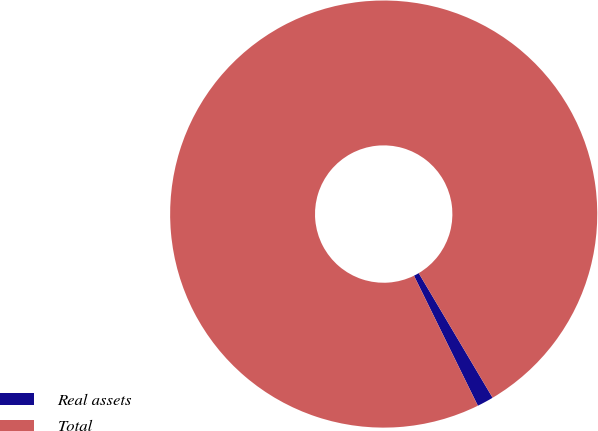Convert chart to OTSL. <chart><loc_0><loc_0><loc_500><loc_500><pie_chart><fcel>Real assets<fcel>Total<nl><fcel>1.25%<fcel>98.75%<nl></chart> 